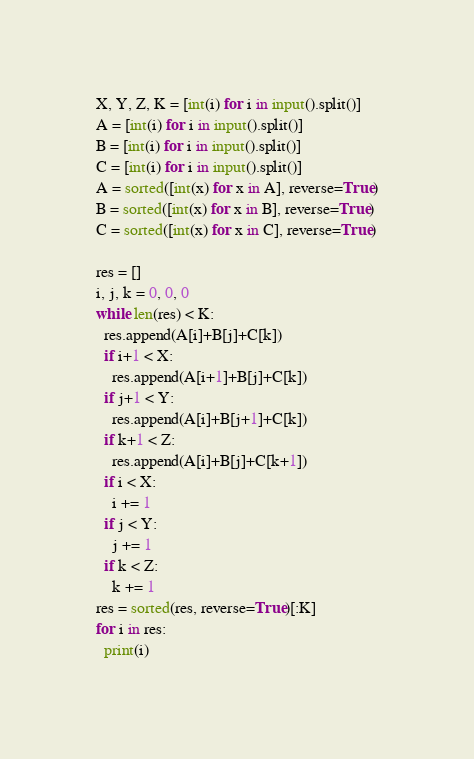<code> <loc_0><loc_0><loc_500><loc_500><_Python_>X, Y, Z, K = [int(i) for i in input().split()]
A = [int(i) for i in input().split()]
B = [int(i) for i in input().split()]
C = [int(i) for i in input().split()]
A = sorted([int(x) for x in A], reverse=True)
B = sorted([int(x) for x in B], reverse=True)
C = sorted([int(x) for x in C], reverse=True)

res = []
i, j, k = 0, 0, 0
while len(res) < K:
  res.append(A[i]+B[j]+C[k])
  if i+1 < X:
  	res.append(A[i+1]+B[j]+C[k])
  if j+1 < Y:
  	res.append(A[i]+B[j+1]+C[k])
  if k+1 < Z:
  	res.append(A[i]+B[j]+C[k+1])
  if i < X:
    i += 1
  if j < Y:
    j += 1
  if k < Z:
    k += 1
res = sorted(res, reverse=True)[:K]
for i in res:
  print(i)</code> 